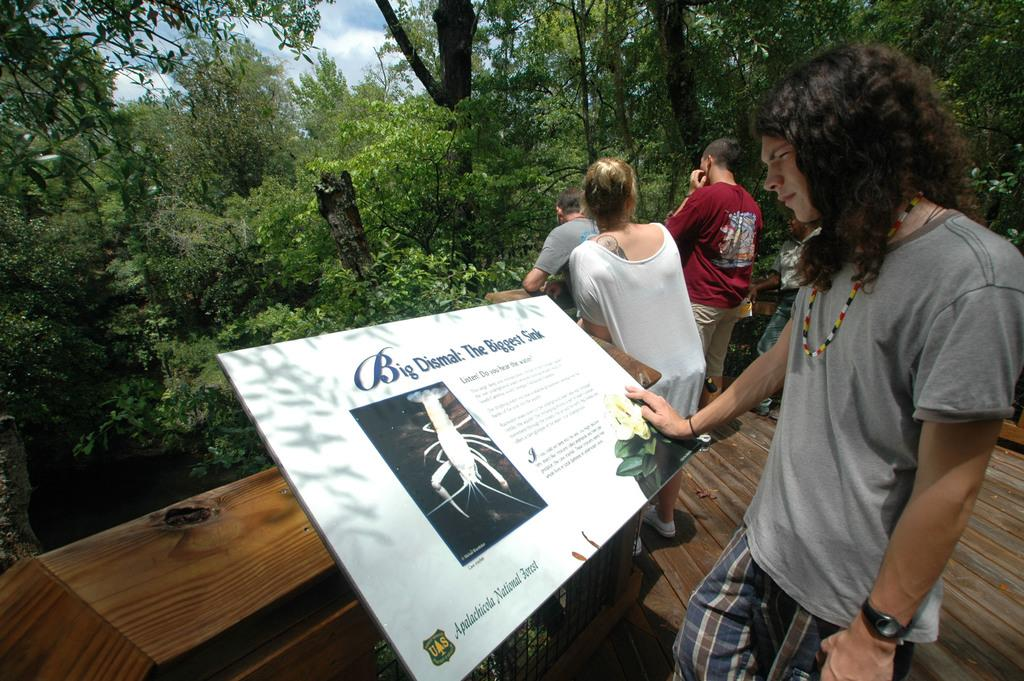What is located in front of the person in the image? There is an information board in front of the person. What can be seen in the background of the image? There are trees and people in the background of the image. What is the condition of the sky in the image? The sky is cloudy in the image. What type of meat is being served to the slaves in the image? There is no mention of meat or slaves in the image; it features an information board, trees, people, and a cloudy sky. 